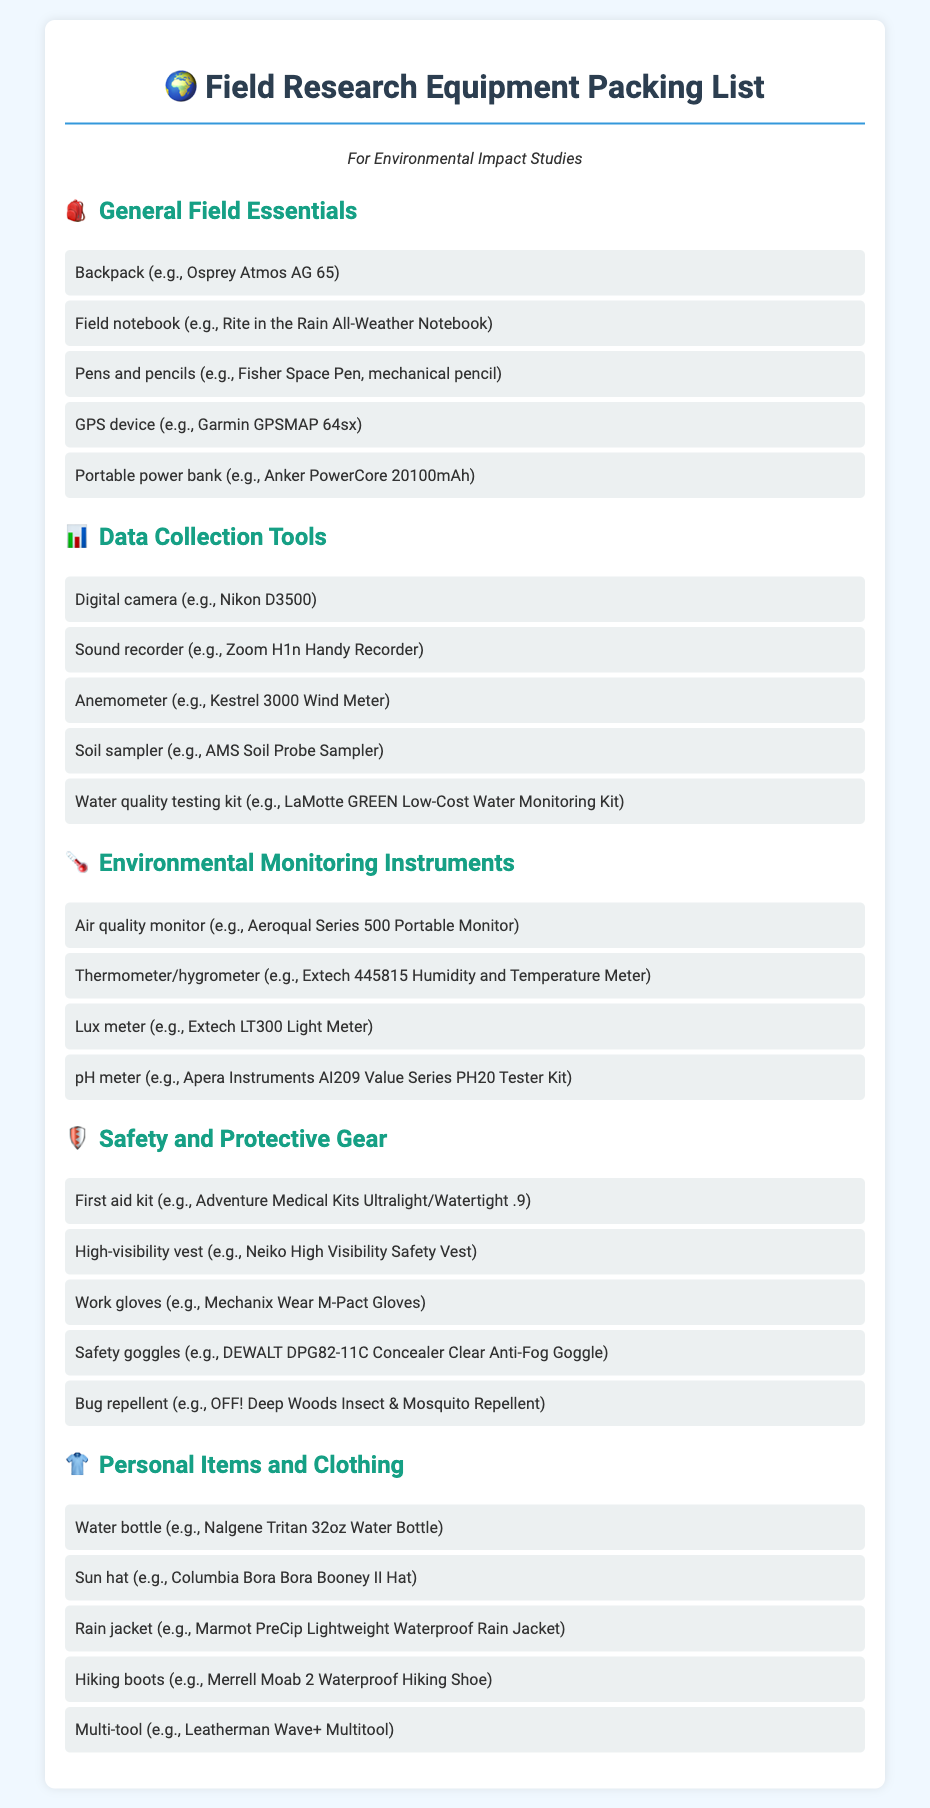What is the category of items that includes a GPS device? The category that includes a GPS device is "General Field Essentials."
Answer: General Field Essentials How many items are listed under "Data Collection Tools"? There are five items listed under "Data Collection Tools."
Answer: 5 What kind of gear is a high-visibility vest classified as? A high-visibility vest is classified as "Safety and Protective Gear."
Answer: Safety and Protective Gear Which item is specified for testing air quality? The item specified for testing air quality is the Aeroqual Series 500 Portable Monitor.
Answer: Aeroqual Series 500 Portable Monitor What personal item can be used to stay hydrated? The personal item that can be used to stay hydrated is a water bottle.
Answer: Water bottle What is the first item listed under "Safety and Protective Gear"? The first item listed under "Safety and Protective Gear" is a first aid kit.
Answer: First aid kit How many categories of items are included in this packing list? There are five categories of items included in this packing list.
Answer: 5 What type of clothing is recommended for rainy conditions? A rain jacket is recommended for rainy conditions.
Answer: Rain jacket 